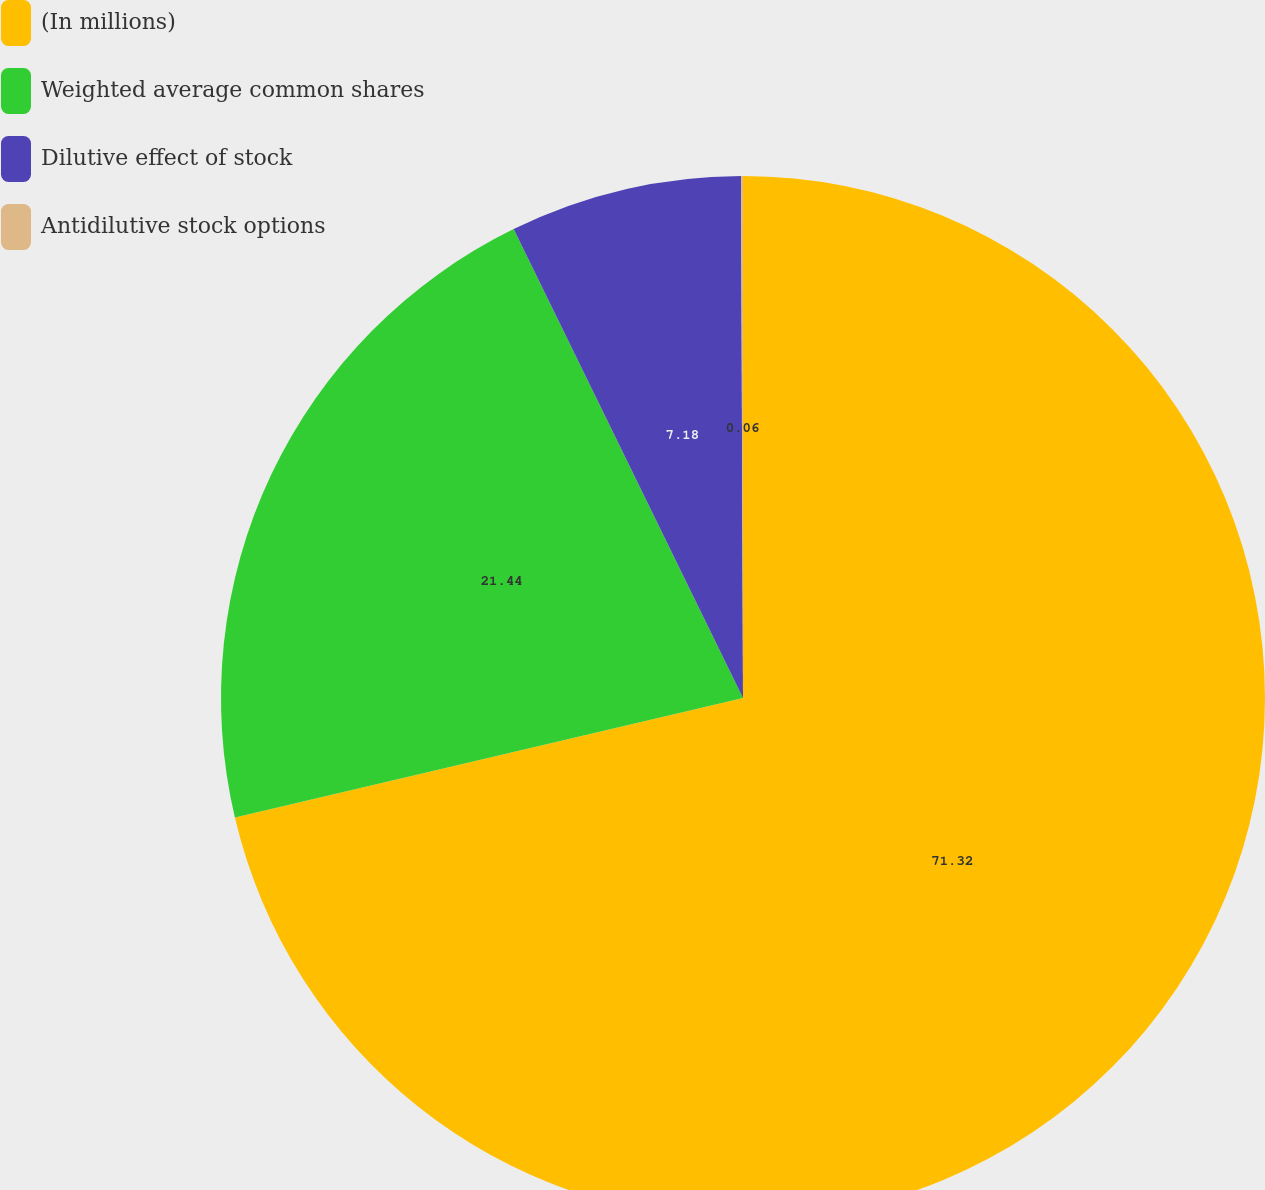<chart> <loc_0><loc_0><loc_500><loc_500><pie_chart><fcel>(In millions)<fcel>Weighted average common shares<fcel>Dilutive effect of stock<fcel>Antidilutive stock options<nl><fcel>71.32%<fcel>21.44%<fcel>7.18%<fcel>0.06%<nl></chart> 